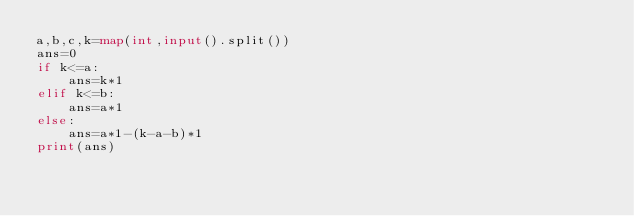<code> <loc_0><loc_0><loc_500><loc_500><_Python_>a,b,c,k=map(int,input().split())
ans=0
if k<=a:
    ans=k*1
elif k<=b:
    ans=a*1
else:
    ans=a*1-(k-a-b)*1
print(ans)</code> 